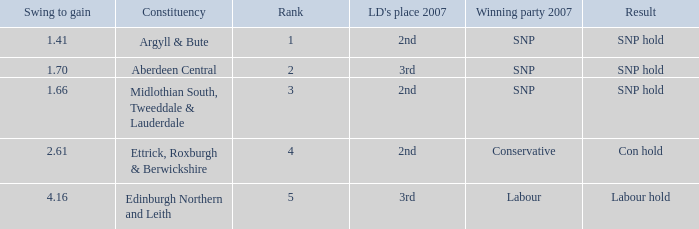How many times is the constituency edinburgh northern and leith? 1.0. 